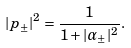<formula> <loc_0><loc_0><loc_500><loc_500>| p _ { \pm } | ^ { 2 } = \frac { 1 } { 1 + | { \alpha } _ { \pm } | ^ { 2 } } .</formula> 